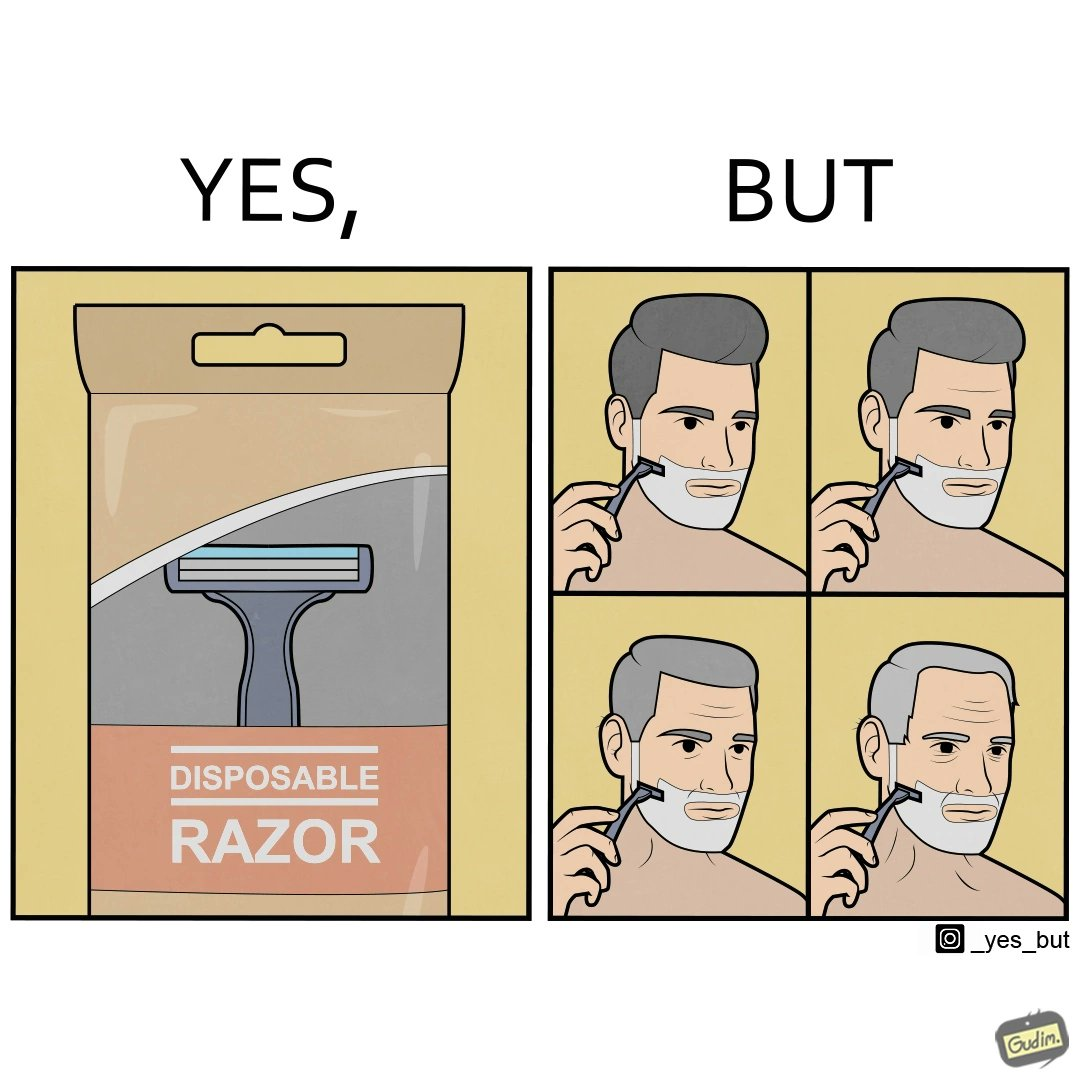Is this image satirical or non-satirical? Yes, this image is satirical. 